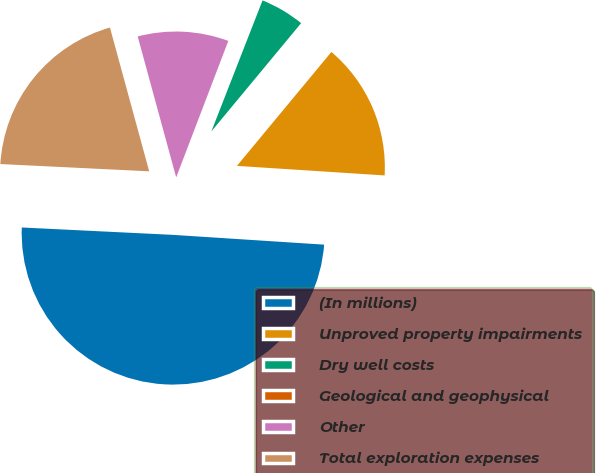Convert chart to OTSL. <chart><loc_0><loc_0><loc_500><loc_500><pie_chart><fcel>(In millions)<fcel>Unproved property impairments<fcel>Dry well costs<fcel>Geological and geophysical<fcel>Other<fcel>Total exploration expenses<nl><fcel>49.75%<fcel>15.01%<fcel>5.09%<fcel>0.12%<fcel>10.05%<fcel>19.98%<nl></chart> 